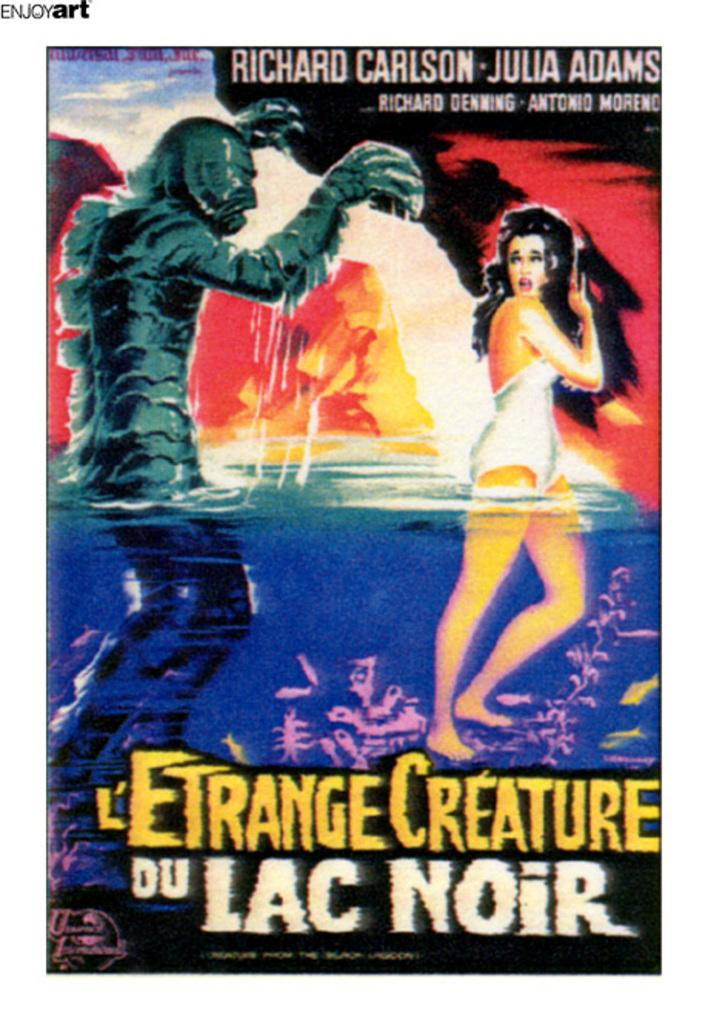Provide a one-sentence caption for the provided image. Julia Adams stars in this film called L"Etrange Creature. 